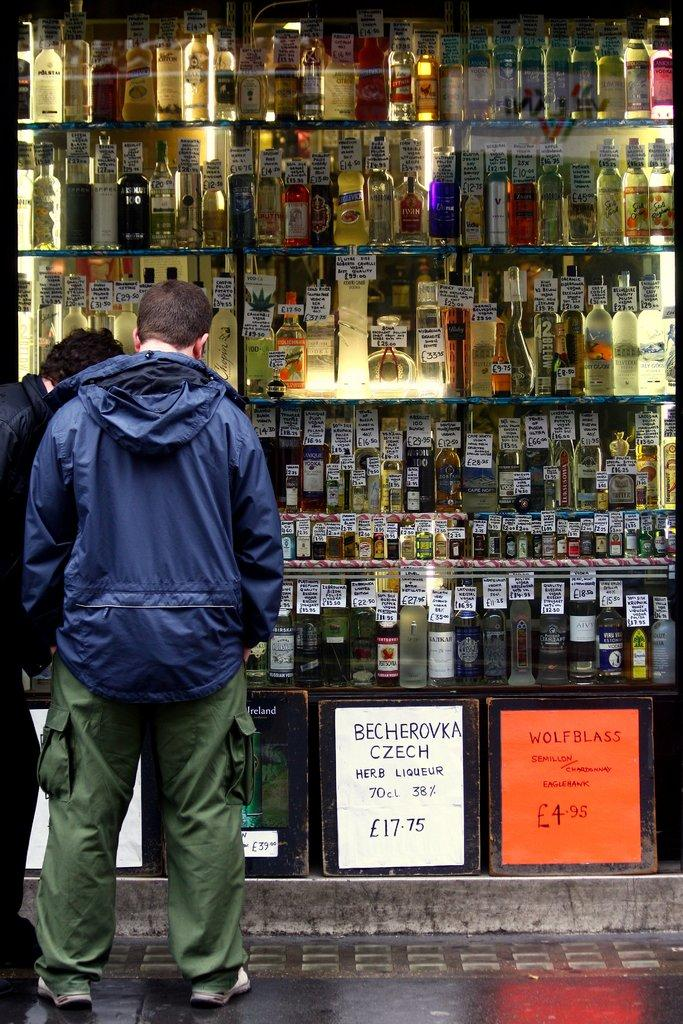Provide a one-sentence caption for the provided image. a man standing in front of a lot of liquor bottles and a sign advertising becherovka czech. 